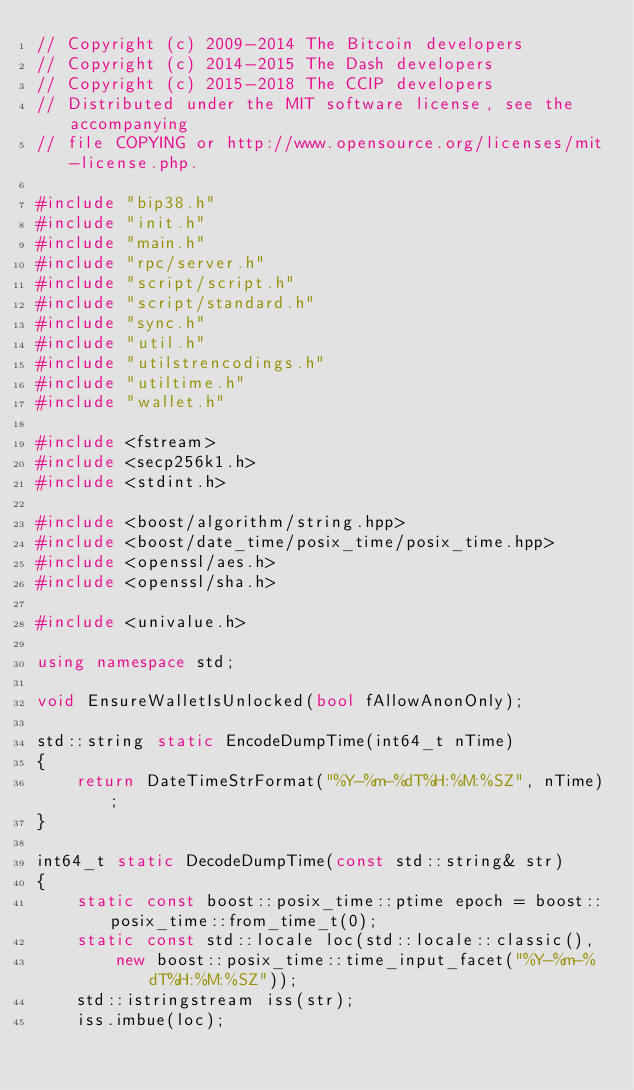<code> <loc_0><loc_0><loc_500><loc_500><_C++_>// Copyright (c) 2009-2014 The Bitcoin developers
// Copyright (c) 2014-2015 The Dash developers
// Copyright (c) 2015-2018 The CCIP developers
// Distributed under the MIT software license, see the accompanying
// file COPYING or http://www.opensource.org/licenses/mit-license.php.

#include "bip38.h"
#include "init.h"
#include "main.h"
#include "rpc/server.h"
#include "script/script.h"
#include "script/standard.h"
#include "sync.h"
#include "util.h"
#include "utilstrencodings.h"
#include "utiltime.h"
#include "wallet.h"

#include <fstream>
#include <secp256k1.h>
#include <stdint.h>

#include <boost/algorithm/string.hpp>
#include <boost/date_time/posix_time/posix_time.hpp>
#include <openssl/aes.h>
#include <openssl/sha.h>

#include <univalue.h>

using namespace std;

void EnsureWalletIsUnlocked(bool fAllowAnonOnly);

std::string static EncodeDumpTime(int64_t nTime)
{
    return DateTimeStrFormat("%Y-%m-%dT%H:%M:%SZ", nTime);
}

int64_t static DecodeDumpTime(const std::string& str)
{
    static const boost::posix_time::ptime epoch = boost::posix_time::from_time_t(0);
    static const std::locale loc(std::locale::classic(),
        new boost::posix_time::time_input_facet("%Y-%m-%dT%H:%M:%SZ"));
    std::istringstream iss(str);
    iss.imbue(loc);</code> 